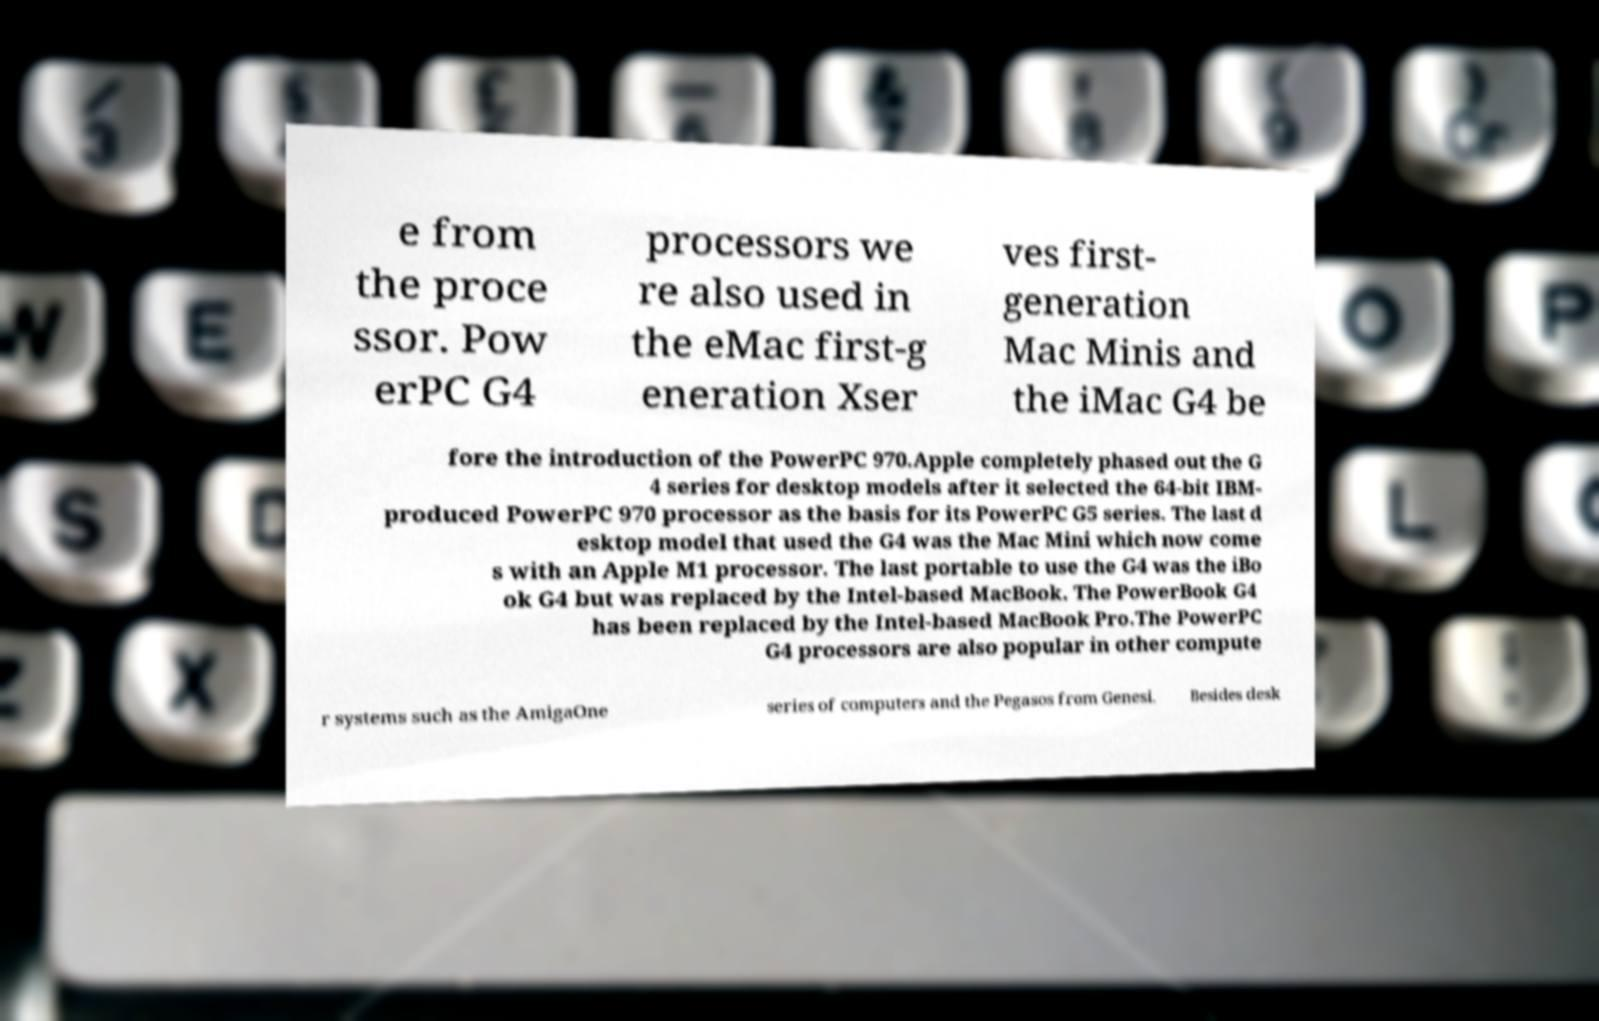There's text embedded in this image that I need extracted. Can you transcribe it verbatim? e from the proce ssor. Pow erPC G4 processors we re also used in the eMac first-g eneration Xser ves first- generation Mac Minis and the iMac G4 be fore the introduction of the PowerPC 970.Apple completely phased out the G 4 series for desktop models after it selected the 64-bit IBM- produced PowerPC 970 processor as the basis for its PowerPC G5 series. The last d esktop model that used the G4 was the Mac Mini which now come s with an Apple M1 processor. The last portable to use the G4 was the iBo ok G4 but was replaced by the Intel-based MacBook. The PowerBook G4 has been replaced by the Intel-based MacBook Pro.The PowerPC G4 processors are also popular in other compute r systems such as the AmigaOne series of computers and the Pegasos from Genesi. Besides desk 